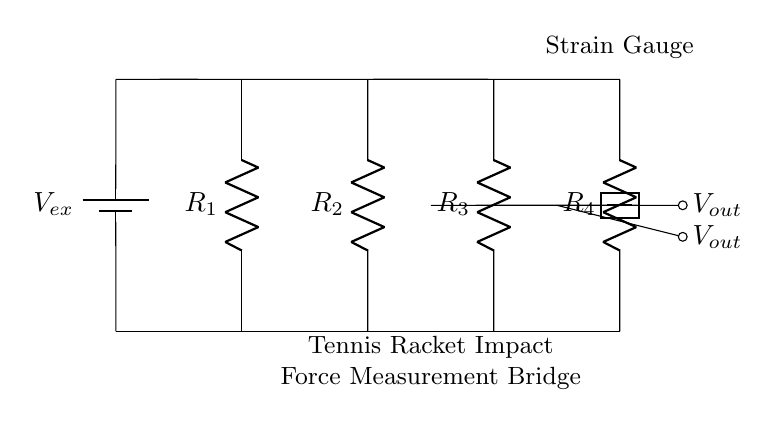What is the purpose of this circuit? The circuit is designed to measure the impact force of a tennis racket by using a strain gauge, which changes resistance based on the deformation caused by the force applied.
Answer: Measure impact force What is the value of the external voltage source? The circuit uses a voltage source labeled as V_ex, but the specific numerical value isn't provided in the diagram. Its purpose is to provide excitation voltage to the bridge circuit.
Answer: Not specified How many resistors are there in this bridge circuit? The circuit diagram contains four resistors labeled as R1, R2, R3, and R4. They are arranged in a connected configuration typical for a Wheatstone bridge setup.
Answer: Four What is the function of the strain gauge in the circuit? The strain gauge, which is represented as R4, measures the change in resistance that occurs due to deformation as impact force is applied to the tennis racket. This change is used to determine the force.
Answer: Measure resistance change What does V_out represent in this circuit? V_out represents the output voltage of the bridge circuit, which is the voltage difference between the two output points in the bridge. This voltage is influenced by the resistance values in the circuit and any changes due to the strain gauge.
Answer: Output voltage Is this circuit balanced or unbalanced? The circuit is initially unbalanced if the resistances R1, R2, and R3 do not equal R4 when under strain, leading to a non-zero output voltage. The balance of the bridge can change dynamically as the strain gauge responds to impact force.
Answer: Unbalanced 